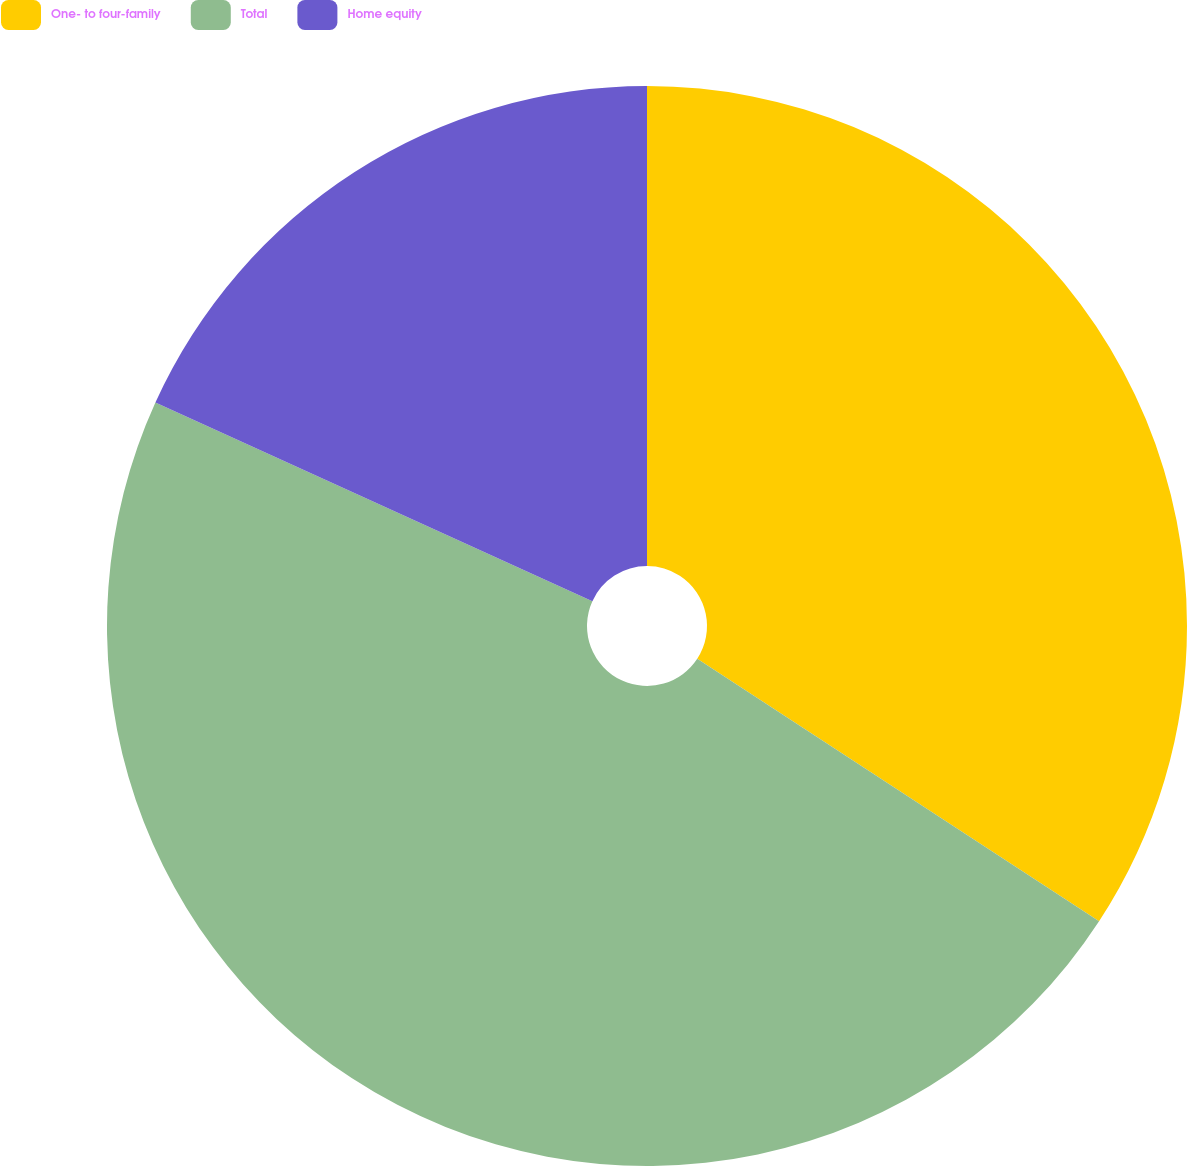Convert chart. <chart><loc_0><loc_0><loc_500><loc_500><pie_chart><fcel>One- to four-family<fcel>Total<fcel>Home equity<nl><fcel>34.21%<fcel>47.58%<fcel>18.21%<nl></chart> 